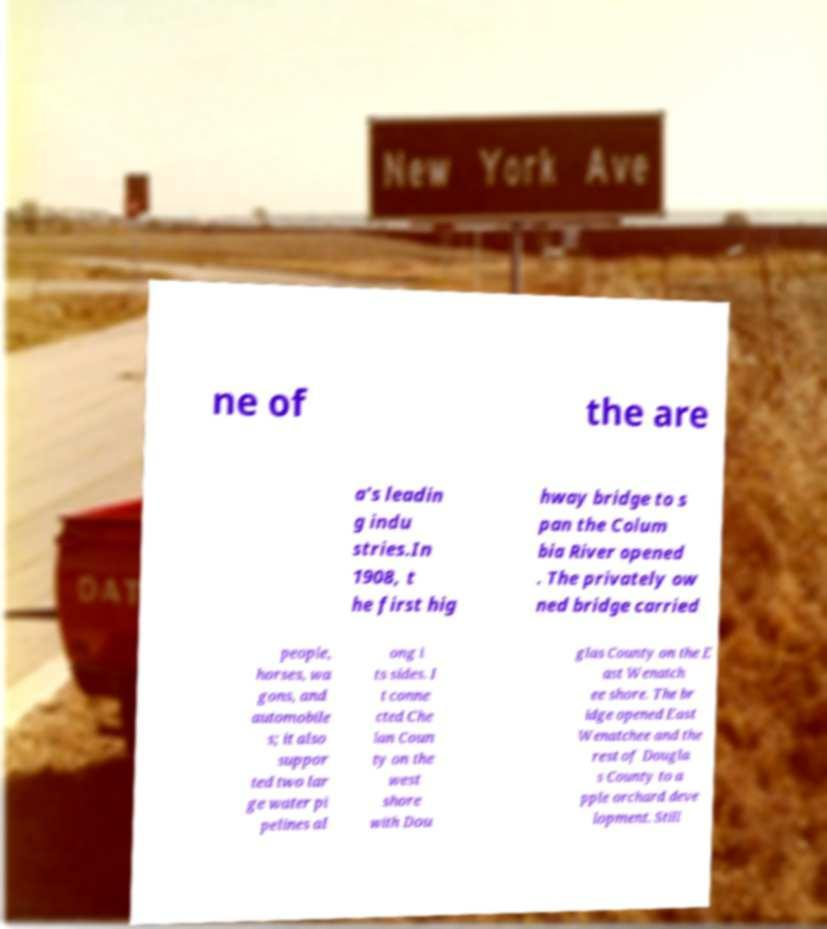Can you accurately transcribe the text from the provided image for me? ne of the are a's leadin g indu stries.In 1908, t he first hig hway bridge to s pan the Colum bia River opened . The privately ow ned bridge carried people, horses, wa gons, and automobile s; it also suppor ted two lar ge water pi pelines al ong i ts sides. I t conne cted Che lan Coun ty on the west shore with Dou glas County on the E ast Wenatch ee shore. The br idge opened East Wenatchee and the rest of Dougla s County to a pple orchard deve lopment. Still 